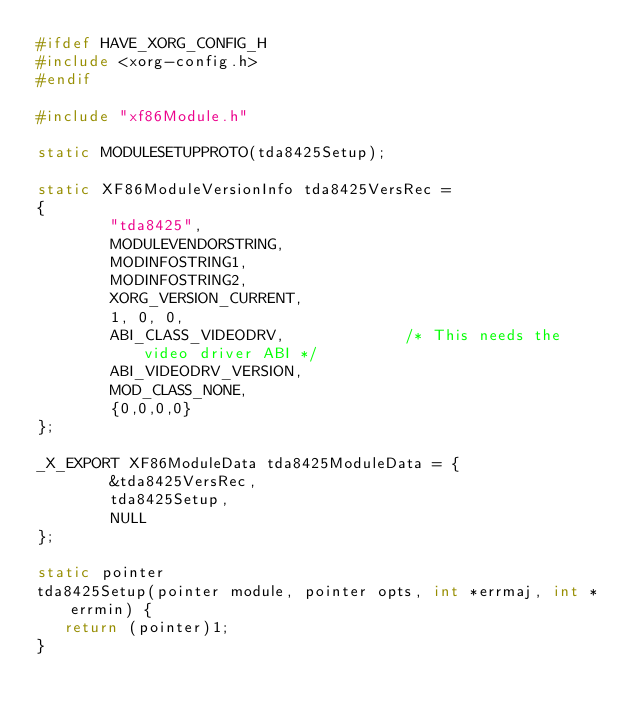Convert code to text. <code><loc_0><loc_0><loc_500><loc_500><_C_>#ifdef HAVE_XORG_CONFIG_H
#include <xorg-config.h>
#endif

#include "xf86Module.h"

static MODULESETUPPROTO(tda8425Setup);

static XF86ModuleVersionInfo tda8425VersRec =
{
        "tda8425",
        MODULEVENDORSTRING,
        MODINFOSTRING1,
        MODINFOSTRING2,
        XORG_VERSION_CURRENT,
        1, 0, 0,
        ABI_CLASS_VIDEODRV,             /* This needs the video driver ABI */
        ABI_VIDEODRV_VERSION,
        MOD_CLASS_NONE,
        {0,0,0,0}
};
 
_X_EXPORT XF86ModuleData tda8425ModuleData = {
        &tda8425VersRec,
        tda8425Setup,
        NULL
}; 

static pointer
tda8425Setup(pointer module, pointer opts, int *errmaj, int *errmin) {
   return (pointer)1;
}
</code> 